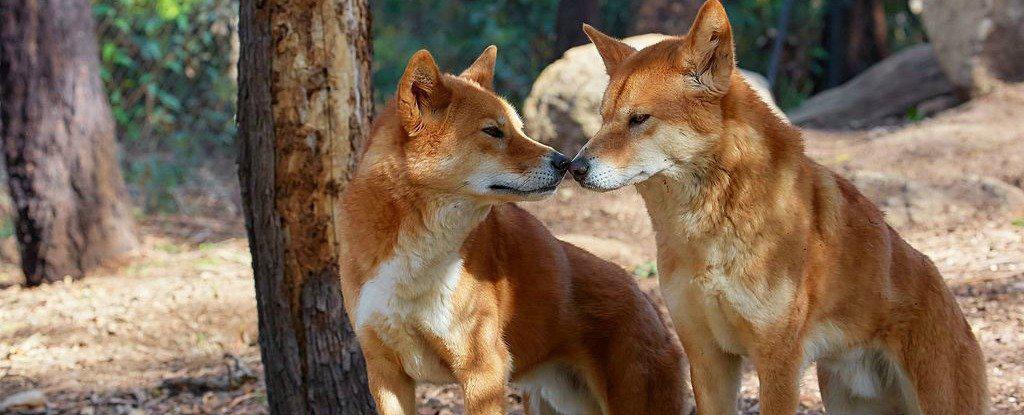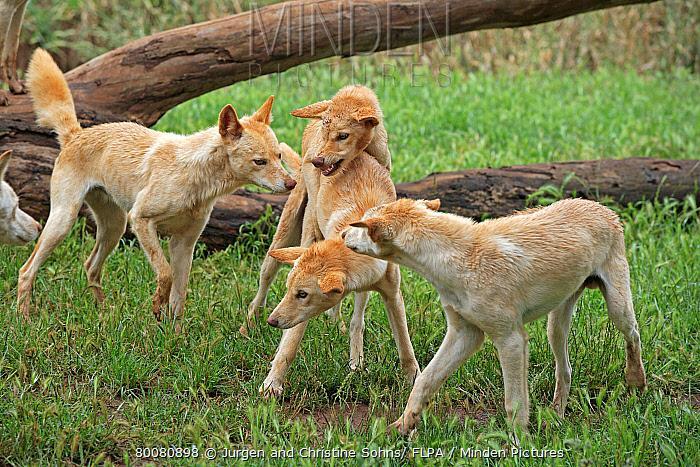The first image is the image on the left, the second image is the image on the right. Evaluate the accuracy of this statement regarding the images: "The left image contains two dingos, with one dog's head turned left and lower than the other right-turned head, and the right image contains no dogs that are not reclining.". Is it true? Answer yes or no. No. 